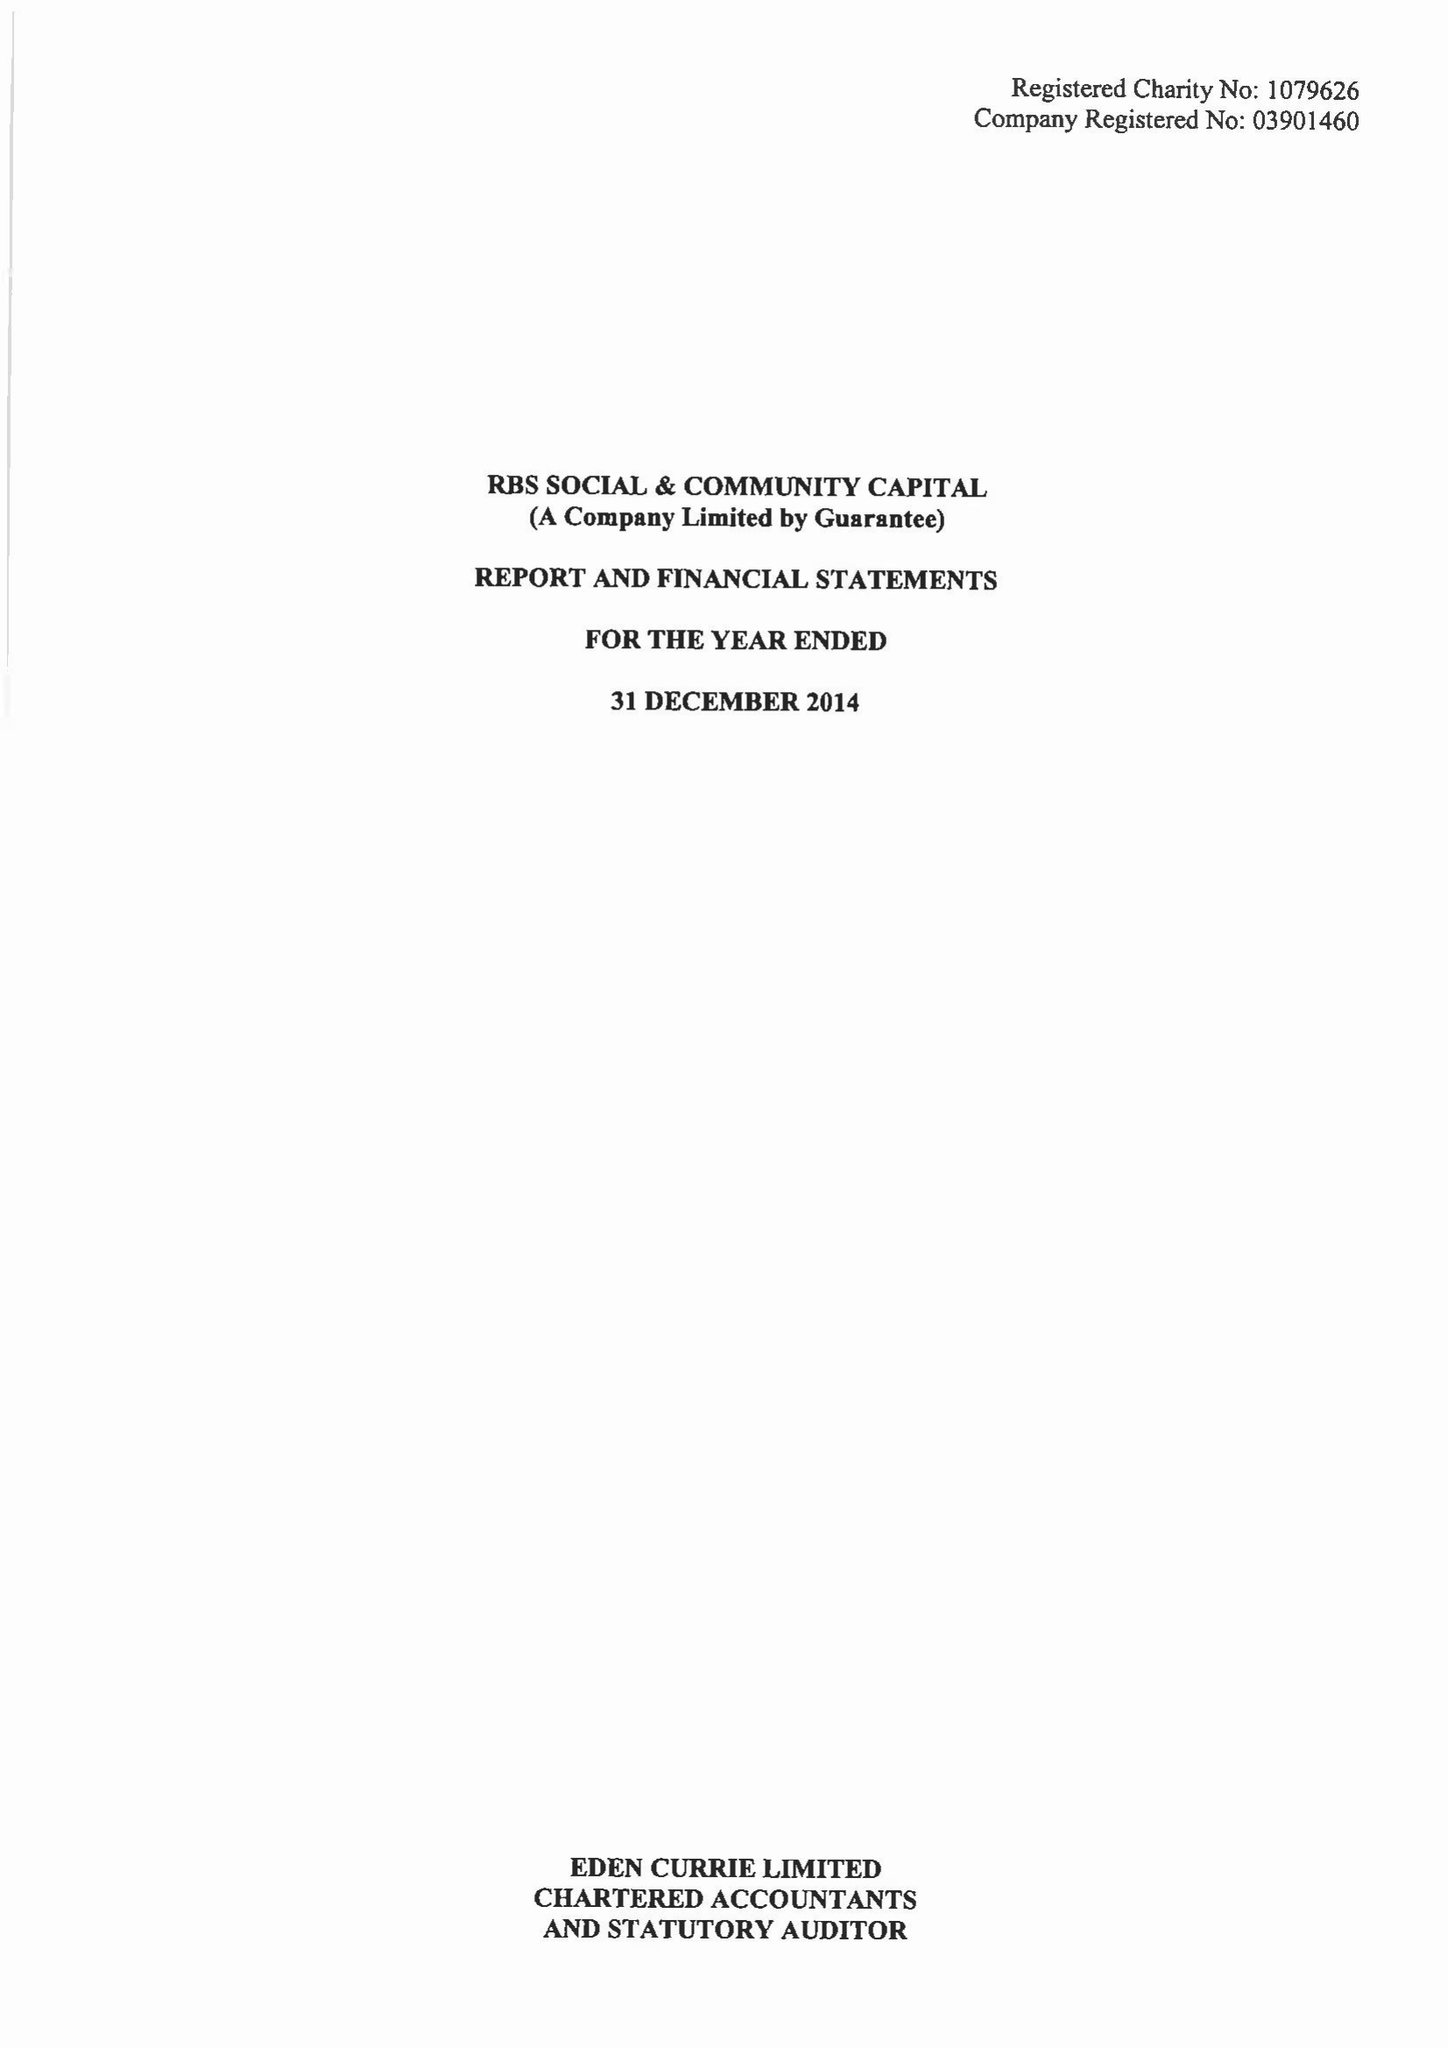What is the value for the address__street_line?
Answer the question using a single word or phrase. 250 BISHOPSGATE 